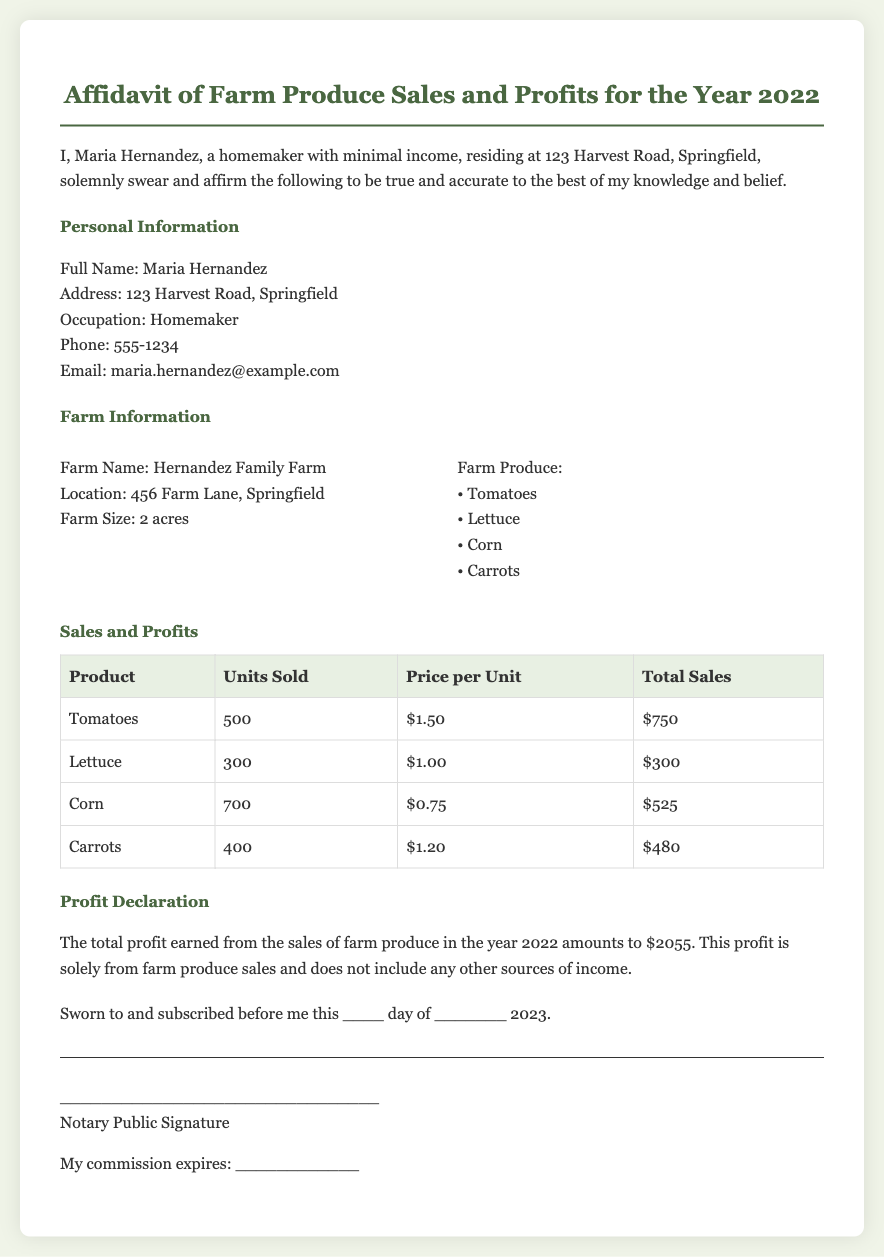What is the full name of the person making the affidavit? The document states the full name of the person as Maria Hernandez.
Answer: Maria Hernandez What is the address listed in the affidavit? The address provided in the document is 123 Harvest Road, Springfield.
Answer: 123 Harvest Road, Springfield What is the total profit earned from farm produce sales in 2022? The document specifies the total profit earned as $2055.
Answer: $2055 How many units of corn were sold? According to the table in the document, 700 units of corn were sold.
Answer: 700 What is the farm name mentioned in the affidavit? The farm name mentioned in the document is Hernandez Family Farm.
Answer: Hernandez Family Farm What is the price per unit of tomatoes? The document indicates the price per unit of tomatoes as $1.50.
Answer: $1.50 How many different types of produce are listed in the affidavit? The document lists four types of produce: Tomatoes, Lettuce, Corn, and Carrots.
Answer: Four Who is the notarizing official mentioned in the document? The document has a placeholder for a notary public's signature but does not specify a name.
Answer: Notary Public Signature 